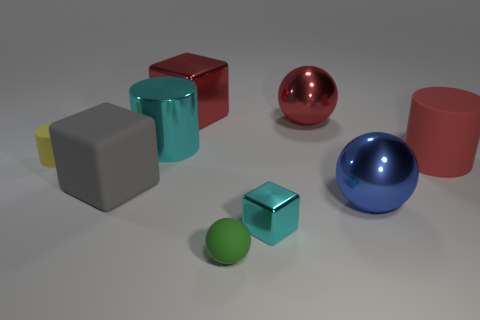Are there any red shiny objects right of the green rubber ball?
Offer a very short reply. Yes. Is there any other thing of the same color as the matte block?
Ensure brevity in your answer.  No. How many cylinders are blue rubber objects or small yellow objects?
Your answer should be very brief. 1. How many things are both in front of the blue metallic sphere and to the right of the green rubber sphere?
Provide a succinct answer. 1. Are there the same number of blocks to the left of the yellow cylinder and large blue spheres that are in front of the small metal block?
Ensure brevity in your answer.  Yes. There is a large red shiny thing that is behind the large red ball; does it have the same shape as the small metal thing?
Offer a very short reply. Yes. What shape is the large red shiny object behind the big red shiny object right of the block behind the cyan metal cylinder?
Give a very brief answer. Cube. What shape is the big thing that is the same color as the small metal cube?
Offer a terse response. Cylinder. What is the ball that is in front of the tiny yellow rubber thing and behind the tiny metal block made of?
Provide a succinct answer. Metal. Are there fewer tiny balls than big gray matte cylinders?
Make the answer very short. No. 